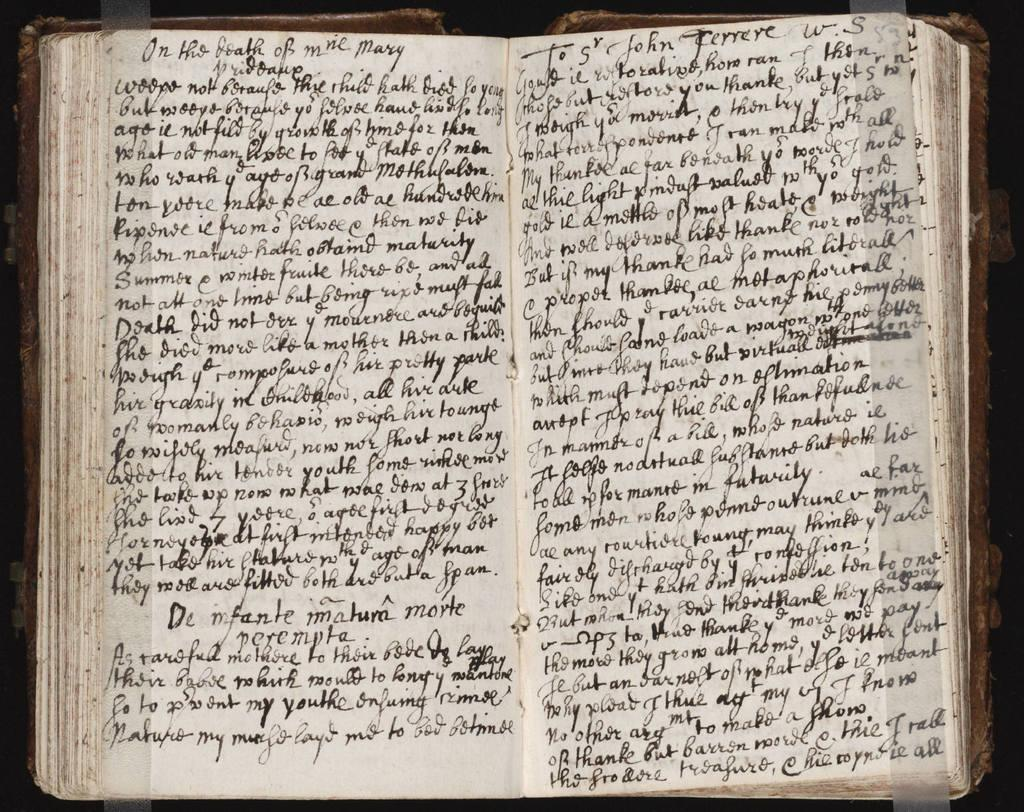What object can be seen in the image? There is a book in the image. What can be found inside the book? There is text written in the book. What type of battle is depicted in the book? There is no battle depicted in the book, as the facts only mention that there is text written in the book. 